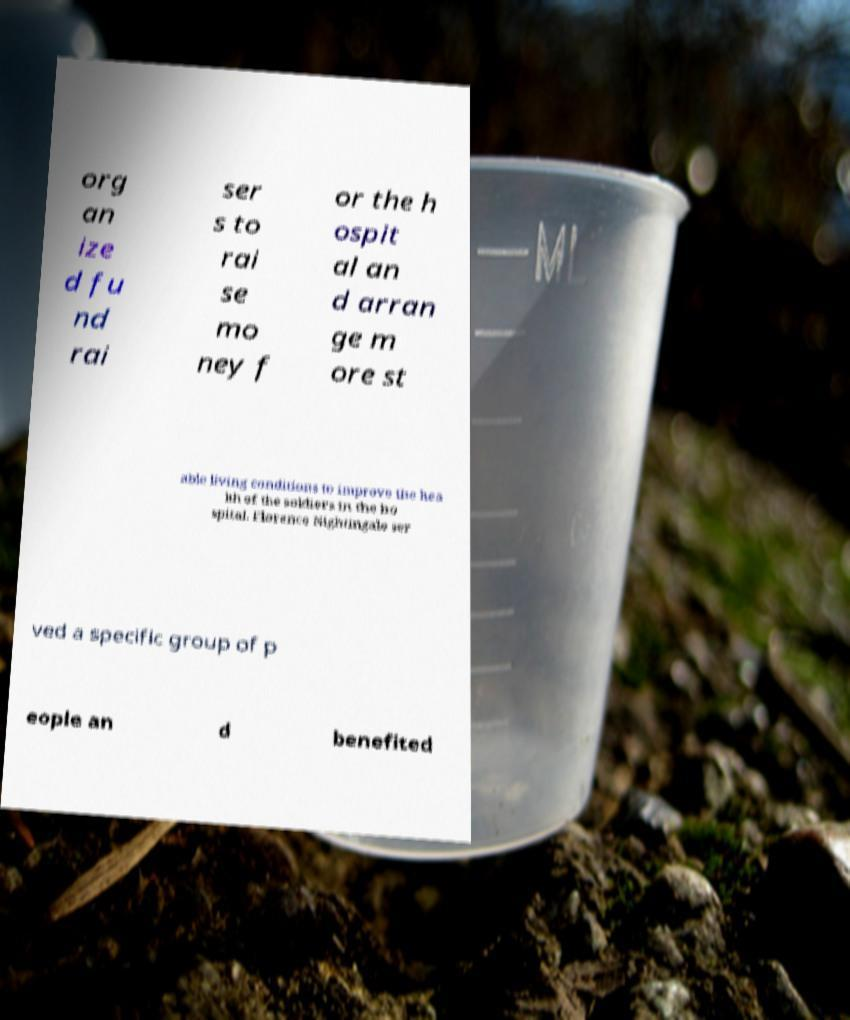What messages or text are displayed in this image? I need them in a readable, typed format. org an ize d fu nd rai ser s to rai se mo ney f or the h ospit al an d arran ge m ore st able living conditions to improve the hea lth of the soldiers in the ho spital. Florence Nightingale ser ved a specific group of p eople an d benefited 